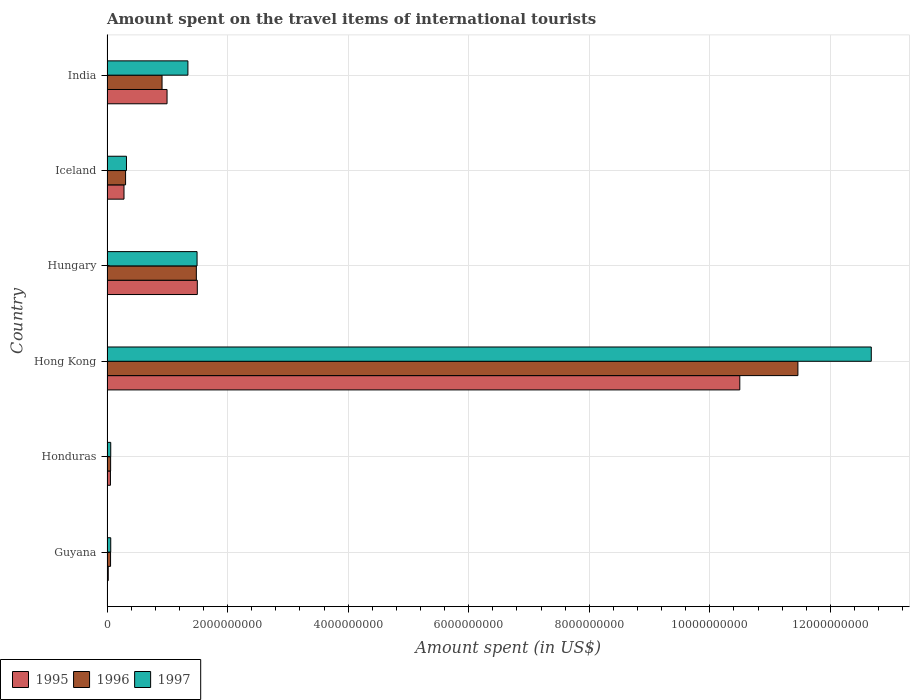How many different coloured bars are there?
Your answer should be compact. 3. How many groups of bars are there?
Make the answer very short. 6. Are the number of bars per tick equal to the number of legend labels?
Provide a succinct answer. Yes. How many bars are there on the 5th tick from the top?
Offer a very short reply. 3. How many bars are there on the 3rd tick from the bottom?
Ensure brevity in your answer.  3. What is the label of the 4th group of bars from the top?
Offer a very short reply. Hong Kong. What is the amount spent on the travel items of international tourists in 1996 in India?
Your answer should be very brief. 9.13e+08. Across all countries, what is the maximum amount spent on the travel items of international tourists in 1997?
Provide a short and direct response. 1.27e+1. Across all countries, what is the minimum amount spent on the travel items of international tourists in 1996?
Your answer should be very brief. 5.90e+07. In which country was the amount spent on the travel items of international tourists in 1995 maximum?
Your answer should be very brief. Hong Kong. In which country was the amount spent on the travel items of international tourists in 1997 minimum?
Give a very brief answer. Guyana. What is the total amount spent on the travel items of international tourists in 1996 in the graph?
Your response must be concise. 1.43e+1. What is the difference between the amount spent on the travel items of international tourists in 1997 in Honduras and that in Hungary?
Your answer should be compact. -1.43e+09. What is the difference between the amount spent on the travel items of international tourists in 1997 in Hong Kong and the amount spent on the travel items of international tourists in 1996 in Iceland?
Offer a very short reply. 1.24e+1. What is the average amount spent on the travel items of international tourists in 1995 per country?
Provide a short and direct response. 2.23e+09. What is the difference between the amount spent on the travel items of international tourists in 1997 and amount spent on the travel items of international tourists in 1996 in Honduras?
Offer a terse response. 2.00e+06. In how many countries, is the amount spent on the travel items of international tourists in 1997 greater than 7600000000 US$?
Your response must be concise. 1. What is the ratio of the amount spent on the travel items of international tourists in 1995 in Honduras to that in Hong Kong?
Make the answer very short. 0.01. Is the amount spent on the travel items of international tourists in 1997 in Honduras less than that in Iceland?
Ensure brevity in your answer.  Yes. What is the difference between the highest and the second highest amount spent on the travel items of international tourists in 1995?
Make the answer very short. 9.00e+09. What is the difference between the highest and the lowest amount spent on the travel items of international tourists in 1997?
Keep it short and to the point. 1.26e+1. In how many countries, is the amount spent on the travel items of international tourists in 1996 greater than the average amount spent on the travel items of international tourists in 1996 taken over all countries?
Your answer should be very brief. 1. Is the sum of the amount spent on the travel items of international tourists in 1995 in Guyana and Honduras greater than the maximum amount spent on the travel items of international tourists in 1997 across all countries?
Provide a short and direct response. No. Is it the case that in every country, the sum of the amount spent on the travel items of international tourists in 1997 and amount spent on the travel items of international tourists in 1996 is greater than the amount spent on the travel items of international tourists in 1995?
Give a very brief answer. Yes. How many bars are there?
Give a very brief answer. 18. Are all the bars in the graph horizontal?
Offer a terse response. Yes. How many countries are there in the graph?
Your response must be concise. 6. What is the difference between two consecutive major ticks on the X-axis?
Provide a succinct answer. 2.00e+09. Are the values on the major ticks of X-axis written in scientific E-notation?
Make the answer very short. No. What is the title of the graph?
Your answer should be compact. Amount spent on the travel items of international tourists. Does "2007" appear as one of the legend labels in the graph?
Keep it short and to the point. No. What is the label or title of the X-axis?
Provide a short and direct response. Amount spent (in US$). What is the Amount spent (in US$) of 1995 in Guyana?
Provide a succinct answer. 2.10e+07. What is the Amount spent (in US$) in 1996 in Guyana?
Your answer should be compact. 5.90e+07. What is the Amount spent (in US$) of 1997 in Guyana?
Keep it short and to the point. 6.20e+07. What is the Amount spent (in US$) of 1995 in Honduras?
Your response must be concise. 5.70e+07. What is the Amount spent (in US$) of 1996 in Honduras?
Give a very brief answer. 6.00e+07. What is the Amount spent (in US$) in 1997 in Honduras?
Ensure brevity in your answer.  6.20e+07. What is the Amount spent (in US$) of 1995 in Hong Kong?
Your response must be concise. 1.05e+1. What is the Amount spent (in US$) of 1996 in Hong Kong?
Provide a succinct answer. 1.15e+1. What is the Amount spent (in US$) in 1997 in Hong Kong?
Offer a terse response. 1.27e+1. What is the Amount spent (in US$) of 1995 in Hungary?
Provide a short and direct response. 1.50e+09. What is the Amount spent (in US$) of 1996 in Hungary?
Give a very brief answer. 1.48e+09. What is the Amount spent (in US$) in 1997 in Hungary?
Keep it short and to the point. 1.49e+09. What is the Amount spent (in US$) of 1995 in Iceland?
Ensure brevity in your answer.  2.82e+08. What is the Amount spent (in US$) in 1996 in Iceland?
Provide a short and direct response. 3.08e+08. What is the Amount spent (in US$) in 1997 in Iceland?
Offer a terse response. 3.23e+08. What is the Amount spent (in US$) in 1995 in India?
Offer a terse response. 9.96e+08. What is the Amount spent (in US$) of 1996 in India?
Provide a short and direct response. 9.13e+08. What is the Amount spent (in US$) of 1997 in India?
Give a very brief answer. 1.34e+09. Across all countries, what is the maximum Amount spent (in US$) of 1995?
Ensure brevity in your answer.  1.05e+1. Across all countries, what is the maximum Amount spent (in US$) in 1996?
Provide a short and direct response. 1.15e+1. Across all countries, what is the maximum Amount spent (in US$) in 1997?
Offer a terse response. 1.27e+1. Across all countries, what is the minimum Amount spent (in US$) of 1995?
Your answer should be compact. 2.10e+07. Across all countries, what is the minimum Amount spent (in US$) of 1996?
Your response must be concise. 5.90e+07. Across all countries, what is the minimum Amount spent (in US$) of 1997?
Offer a very short reply. 6.20e+07. What is the total Amount spent (in US$) in 1995 in the graph?
Your answer should be compact. 1.34e+1. What is the total Amount spent (in US$) in 1996 in the graph?
Offer a terse response. 1.43e+1. What is the total Amount spent (in US$) in 1997 in the graph?
Provide a succinct answer. 1.60e+1. What is the difference between the Amount spent (in US$) in 1995 in Guyana and that in Honduras?
Your answer should be compact. -3.60e+07. What is the difference between the Amount spent (in US$) of 1996 in Guyana and that in Honduras?
Provide a short and direct response. -1.00e+06. What is the difference between the Amount spent (in US$) in 1997 in Guyana and that in Honduras?
Offer a very short reply. 0. What is the difference between the Amount spent (in US$) of 1995 in Guyana and that in Hong Kong?
Your answer should be compact. -1.05e+1. What is the difference between the Amount spent (in US$) in 1996 in Guyana and that in Hong Kong?
Your answer should be compact. -1.14e+1. What is the difference between the Amount spent (in US$) in 1997 in Guyana and that in Hong Kong?
Give a very brief answer. -1.26e+1. What is the difference between the Amount spent (in US$) of 1995 in Guyana and that in Hungary?
Your answer should be very brief. -1.48e+09. What is the difference between the Amount spent (in US$) of 1996 in Guyana and that in Hungary?
Keep it short and to the point. -1.42e+09. What is the difference between the Amount spent (in US$) in 1997 in Guyana and that in Hungary?
Your answer should be compact. -1.43e+09. What is the difference between the Amount spent (in US$) of 1995 in Guyana and that in Iceland?
Give a very brief answer. -2.61e+08. What is the difference between the Amount spent (in US$) of 1996 in Guyana and that in Iceland?
Give a very brief answer. -2.49e+08. What is the difference between the Amount spent (in US$) of 1997 in Guyana and that in Iceland?
Your response must be concise. -2.61e+08. What is the difference between the Amount spent (in US$) of 1995 in Guyana and that in India?
Provide a succinct answer. -9.75e+08. What is the difference between the Amount spent (in US$) in 1996 in Guyana and that in India?
Offer a terse response. -8.54e+08. What is the difference between the Amount spent (in US$) in 1997 in Guyana and that in India?
Offer a terse response. -1.28e+09. What is the difference between the Amount spent (in US$) of 1995 in Honduras and that in Hong Kong?
Give a very brief answer. -1.04e+1. What is the difference between the Amount spent (in US$) in 1996 in Honduras and that in Hong Kong?
Ensure brevity in your answer.  -1.14e+1. What is the difference between the Amount spent (in US$) in 1997 in Honduras and that in Hong Kong?
Give a very brief answer. -1.26e+1. What is the difference between the Amount spent (in US$) in 1995 in Honduras and that in Hungary?
Provide a succinct answer. -1.44e+09. What is the difference between the Amount spent (in US$) in 1996 in Honduras and that in Hungary?
Your response must be concise. -1.42e+09. What is the difference between the Amount spent (in US$) of 1997 in Honduras and that in Hungary?
Ensure brevity in your answer.  -1.43e+09. What is the difference between the Amount spent (in US$) in 1995 in Honduras and that in Iceland?
Give a very brief answer. -2.25e+08. What is the difference between the Amount spent (in US$) in 1996 in Honduras and that in Iceland?
Provide a succinct answer. -2.48e+08. What is the difference between the Amount spent (in US$) in 1997 in Honduras and that in Iceland?
Your response must be concise. -2.61e+08. What is the difference between the Amount spent (in US$) in 1995 in Honduras and that in India?
Give a very brief answer. -9.39e+08. What is the difference between the Amount spent (in US$) of 1996 in Honduras and that in India?
Ensure brevity in your answer.  -8.53e+08. What is the difference between the Amount spent (in US$) in 1997 in Honduras and that in India?
Offer a very short reply. -1.28e+09. What is the difference between the Amount spent (in US$) of 1995 in Hong Kong and that in Hungary?
Ensure brevity in your answer.  9.00e+09. What is the difference between the Amount spent (in US$) of 1996 in Hong Kong and that in Hungary?
Make the answer very short. 9.98e+09. What is the difference between the Amount spent (in US$) of 1997 in Hong Kong and that in Hungary?
Offer a very short reply. 1.12e+1. What is the difference between the Amount spent (in US$) of 1995 in Hong Kong and that in Iceland?
Your answer should be very brief. 1.02e+1. What is the difference between the Amount spent (in US$) in 1996 in Hong Kong and that in Iceland?
Make the answer very short. 1.12e+1. What is the difference between the Amount spent (in US$) in 1997 in Hong Kong and that in Iceland?
Make the answer very short. 1.24e+1. What is the difference between the Amount spent (in US$) in 1995 in Hong Kong and that in India?
Provide a short and direct response. 9.50e+09. What is the difference between the Amount spent (in US$) in 1996 in Hong Kong and that in India?
Your answer should be compact. 1.05e+1. What is the difference between the Amount spent (in US$) of 1997 in Hong Kong and that in India?
Give a very brief answer. 1.13e+1. What is the difference between the Amount spent (in US$) of 1995 in Hungary and that in Iceland?
Your response must be concise. 1.22e+09. What is the difference between the Amount spent (in US$) in 1996 in Hungary and that in Iceland?
Make the answer very short. 1.17e+09. What is the difference between the Amount spent (in US$) in 1997 in Hungary and that in Iceland?
Offer a very short reply. 1.17e+09. What is the difference between the Amount spent (in US$) of 1995 in Hungary and that in India?
Keep it short and to the point. 5.02e+08. What is the difference between the Amount spent (in US$) of 1996 in Hungary and that in India?
Offer a terse response. 5.69e+08. What is the difference between the Amount spent (in US$) of 1997 in Hungary and that in India?
Keep it short and to the point. 1.52e+08. What is the difference between the Amount spent (in US$) in 1995 in Iceland and that in India?
Provide a succinct answer. -7.14e+08. What is the difference between the Amount spent (in US$) of 1996 in Iceland and that in India?
Provide a succinct answer. -6.05e+08. What is the difference between the Amount spent (in US$) in 1997 in Iceland and that in India?
Make the answer very short. -1.02e+09. What is the difference between the Amount spent (in US$) of 1995 in Guyana and the Amount spent (in US$) of 1996 in Honduras?
Provide a short and direct response. -3.90e+07. What is the difference between the Amount spent (in US$) of 1995 in Guyana and the Amount spent (in US$) of 1997 in Honduras?
Your response must be concise. -4.10e+07. What is the difference between the Amount spent (in US$) of 1996 in Guyana and the Amount spent (in US$) of 1997 in Honduras?
Your response must be concise. -3.00e+06. What is the difference between the Amount spent (in US$) of 1995 in Guyana and the Amount spent (in US$) of 1996 in Hong Kong?
Offer a very short reply. -1.14e+1. What is the difference between the Amount spent (in US$) of 1995 in Guyana and the Amount spent (in US$) of 1997 in Hong Kong?
Your answer should be very brief. -1.27e+1. What is the difference between the Amount spent (in US$) of 1996 in Guyana and the Amount spent (in US$) of 1997 in Hong Kong?
Keep it short and to the point. -1.26e+1. What is the difference between the Amount spent (in US$) in 1995 in Guyana and the Amount spent (in US$) in 1996 in Hungary?
Offer a terse response. -1.46e+09. What is the difference between the Amount spent (in US$) in 1995 in Guyana and the Amount spent (in US$) in 1997 in Hungary?
Keep it short and to the point. -1.47e+09. What is the difference between the Amount spent (in US$) of 1996 in Guyana and the Amount spent (in US$) of 1997 in Hungary?
Give a very brief answer. -1.44e+09. What is the difference between the Amount spent (in US$) of 1995 in Guyana and the Amount spent (in US$) of 1996 in Iceland?
Your response must be concise. -2.87e+08. What is the difference between the Amount spent (in US$) in 1995 in Guyana and the Amount spent (in US$) in 1997 in Iceland?
Your answer should be very brief. -3.02e+08. What is the difference between the Amount spent (in US$) in 1996 in Guyana and the Amount spent (in US$) in 1997 in Iceland?
Your answer should be very brief. -2.64e+08. What is the difference between the Amount spent (in US$) of 1995 in Guyana and the Amount spent (in US$) of 1996 in India?
Ensure brevity in your answer.  -8.92e+08. What is the difference between the Amount spent (in US$) of 1995 in Guyana and the Amount spent (in US$) of 1997 in India?
Offer a terse response. -1.32e+09. What is the difference between the Amount spent (in US$) in 1996 in Guyana and the Amount spent (in US$) in 1997 in India?
Offer a very short reply. -1.28e+09. What is the difference between the Amount spent (in US$) of 1995 in Honduras and the Amount spent (in US$) of 1996 in Hong Kong?
Ensure brevity in your answer.  -1.14e+1. What is the difference between the Amount spent (in US$) in 1995 in Honduras and the Amount spent (in US$) in 1997 in Hong Kong?
Provide a short and direct response. -1.26e+1. What is the difference between the Amount spent (in US$) in 1996 in Honduras and the Amount spent (in US$) in 1997 in Hong Kong?
Offer a very short reply. -1.26e+1. What is the difference between the Amount spent (in US$) in 1995 in Honduras and the Amount spent (in US$) in 1996 in Hungary?
Keep it short and to the point. -1.42e+09. What is the difference between the Amount spent (in US$) in 1995 in Honduras and the Amount spent (in US$) in 1997 in Hungary?
Keep it short and to the point. -1.44e+09. What is the difference between the Amount spent (in US$) in 1996 in Honduras and the Amount spent (in US$) in 1997 in Hungary?
Offer a very short reply. -1.43e+09. What is the difference between the Amount spent (in US$) of 1995 in Honduras and the Amount spent (in US$) of 1996 in Iceland?
Provide a succinct answer. -2.51e+08. What is the difference between the Amount spent (in US$) of 1995 in Honduras and the Amount spent (in US$) of 1997 in Iceland?
Ensure brevity in your answer.  -2.66e+08. What is the difference between the Amount spent (in US$) of 1996 in Honduras and the Amount spent (in US$) of 1997 in Iceland?
Your response must be concise. -2.63e+08. What is the difference between the Amount spent (in US$) in 1995 in Honduras and the Amount spent (in US$) in 1996 in India?
Offer a very short reply. -8.56e+08. What is the difference between the Amount spent (in US$) of 1995 in Honduras and the Amount spent (in US$) of 1997 in India?
Your answer should be very brief. -1.28e+09. What is the difference between the Amount spent (in US$) in 1996 in Honduras and the Amount spent (in US$) in 1997 in India?
Your response must be concise. -1.28e+09. What is the difference between the Amount spent (in US$) in 1995 in Hong Kong and the Amount spent (in US$) in 1996 in Hungary?
Provide a succinct answer. 9.02e+09. What is the difference between the Amount spent (in US$) in 1995 in Hong Kong and the Amount spent (in US$) in 1997 in Hungary?
Your answer should be compact. 9.00e+09. What is the difference between the Amount spent (in US$) of 1996 in Hong Kong and the Amount spent (in US$) of 1997 in Hungary?
Make the answer very short. 9.97e+09. What is the difference between the Amount spent (in US$) in 1995 in Hong Kong and the Amount spent (in US$) in 1996 in Iceland?
Give a very brief answer. 1.02e+1. What is the difference between the Amount spent (in US$) in 1995 in Hong Kong and the Amount spent (in US$) in 1997 in Iceland?
Offer a very short reply. 1.02e+1. What is the difference between the Amount spent (in US$) in 1996 in Hong Kong and the Amount spent (in US$) in 1997 in Iceland?
Keep it short and to the point. 1.11e+1. What is the difference between the Amount spent (in US$) in 1995 in Hong Kong and the Amount spent (in US$) in 1996 in India?
Offer a terse response. 9.58e+09. What is the difference between the Amount spent (in US$) in 1995 in Hong Kong and the Amount spent (in US$) in 1997 in India?
Give a very brief answer. 9.16e+09. What is the difference between the Amount spent (in US$) in 1996 in Hong Kong and the Amount spent (in US$) in 1997 in India?
Offer a very short reply. 1.01e+1. What is the difference between the Amount spent (in US$) of 1995 in Hungary and the Amount spent (in US$) of 1996 in Iceland?
Your answer should be compact. 1.19e+09. What is the difference between the Amount spent (in US$) in 1995 in Hungary and the Amount spent (in US$) in 1997 in Iceland?
Keep it short and to the point. 1.18e+09. What is the difference between the Amount spent (in US$) of 1996 in Hungary and the Amount spent (in US$) of 1997 in Iceland?
Keep it short and to the point. 1.16e+09. What is the difference between the Amount spent (in US$) in 1995 in Hungary and the Amount spent (in US$) in 1996 in India?
Keep it short and to the point. 5.85e+08. What is the difference between the Amount spent (in US$) of 1995 in Hungary and the Amount spent (in US$) of 1997 in India?
Provide a succinct answer. 1.56e+08. What is the difference between the Amount spent (in US$) of 1996 in Hungary and the Amount spent (in US$) of 1997 in India?
Provide a succinct answer. 1.40e+08. What is the difference between the Amount spent (in US$) of 1995 in Iceland and the Amount spent (in US$) of 1996 in India?
Keep it short and to the point. -6.31e+08. What is the difference between the Amount spent (in US$) in 1995 in Iceland and the Amount spent (in US$) in 1997 in India?
Your answer should be compact. -1.06e+09. What is the difference between the Amount spent (in US$) of 1996 in Iceland and the Amount spent (in US$) of 1997 in India?
Make the answer very short. -1.03e+09. What is the average Amount spent (in US$) in 1995 per country?
Your answer should be very brief. 2.23e+09. What is the average Amount spent (in US$) in 1996 per country?
Offer a very short reply. 2.38e+09. What is the average Amount spent (in US$) of 1997 per country?
Provide a short and direct response. 2.66e+09. What is the difference between the Amount spent (in US$) of 1995 and Amount spent (in US$) of 1996 in Guyana?
Make the answer very short. -3.80e+07. What is the difference between the Amount spent (in US$) in 1995 and Amount spent (in US$) in 1997 in Guyana?
Keep it short and to the point. -4.10e+07. What is the difference between the Amount spent (in US$) in 1995 and Amount spent (in US$) in 1996 in Honduras?
Provide a succinct answer. -3.00e+06. What is the difference between the Amount spent (in US$) of 1995 and Amount spent (in US$) of 1997 in Honduras?
Provide a succinct answer. -5.00e+06. What is the difference between the Amount spent (in US$) of 1996 and Amount spent (in US$) of 1997 in Honduras?
Offer a very short reply. -2.00e+06. What is the difference between the Amount spent (in US$) in 1995 and Amount spent (in US$) in 1996 in Hong Kong?
Provide a succinct answer. -9.64e+08. What is the difference between the Amount spent (in US$) in 1995 and Amount spent (in US$) in 1997 in Hong Kong?
Your response must be concise. -2.18e+09. What is the difference between the Amount spent (in US$) in 1996 and Amount spent (in US$) in 1997 in Hong Kong?
Offer a very short reply. -1.22e+09. What is the difference between the Amount spent (in US$) in 1995 and Amount spent (in US$) in 1996 in Hungary?
Give a very brief answer. 1.60e+07. What is the difference between the Amount spent (in US$) of 1996 and Amount spent (in US$) of 1997 in Hungary?
Offer a very short reply. -1.20e+07. What is the difference between the Amount spent (in US$) in 1995 and Amount spent (in US$) in 1996 in Iceland?
Your answer should be compact. -2.60e+07. What is the difference between the Amount spent (in US$) of 1995 and Amount spent (in US$) of 1997 in Iceland?
Provide a succinct answer. -4.10e+07. What is the difference between the Amount spent (in US$) of 1996 and Amount spent (in US$) of 1997 in Iceland?
Provide a succinct answer. -1.50e+07. What is the difference between the Amount spent (in US$) of 1995 and Amount spent (in US$) of 1996 in India?
Give a very brief answer. 8.30e+07. What is the difference between the Amount spent (in US$) of 1995 and Amount spent (in US$) of 1997 in India?
Give a very brief answer. -3.46e+08. What is the difference between the Amount spent (in US$) of 1996 and Amount spent (in US$) of 1997 in India?
Your response must be concise. -4.29e+08. What is the ratio of the Amount spent (in US$) of 1995 in Guyana to that in Honduras?
Your answer should be very brief. 0.37. What is the ratio of the Amount spent (in US$) in 1996 in Guyana to that in Honduras?
Make the answer very short. 0.98. What is the ratio of the Amount spent (in US$) of 1997 in Guyana to that in Honduras?
Make the answer very short. 1. What is the ratio of the Amount spent (in US$) of 1995 in Guyana to that in Hong Kong?
Offer a terse response. 0. What is the ratio of the Amount spent (in US$) of 1996 in Guyana to that in Hong Kong?
Keep it short and to the point. 0.01. What is the ratio of the Amount spent (in US$) of 1997 in Guyana to that in Hong Kong?
Your response must be concise. 0. What is the ratio of the Amount spent (in US$) of 1995 in Guyana to that in Hungary?
Make the answer very short. 0.01. What is the ratio of the Amount spent (in US$) of 1996 in Guyana to that in Hungary?
Offer a terse response. 0.04. What is the ratio of the Amount spent (in US$) of 1997 in Guyana to that in Hungary?
Offer a very short reply. 0.04. What is the ratio of the Amount spent (in US$) in 1995 in Guyana to that in Iceland?
Your answer should be compact. 0.07. What is the ratio of the Amount spent (in US$) of 1996 in Guyana to that in Iceland?
Provide a short and direct response. 0.19. What is the ratio of the Amount spent (in US$) in 1997 in Guyana to that in Iceland?
Your response must be concise. 0.19. What is the ratio of the Amount spent (in US$) in 1995 in Guyana to that in India?
Your answer should be compact. 0.02. What is the ratio of the Amount spent (in US$) of 1996 in Guyana to that in India?
Ensure brevity in your answer.  0.06. What is the ratio of the Amount spent (in US$) of 1997 in Guyana to that in India?
Offer a very short reply. 0.05. What is the ratio of the Amount spent (in US$) in 1995 in Honduras to that in Hong Kong?
Your response must be concise. 0.01. What is the ratio of the Amount spent (in US$) of 1996 in Honduras to that in Hong Kong?
Offer a very short reply. 0.01. What is the ratio of the Amount spent (in US$) in 1997 in Honduras to that in Hong Kong?
Ensure brevity in your answer.  0. What is the ratio of the Amount spent (in US$) of 1995 in Honduras to that in Hungary?
Your answer should be compact. 0.04. What is the ratio of the Amount spent (in US$) in 1996 in Honduras to that in Hungary?
Ensure brevity in your answer.  0.04. What is the ratio of the Amount spent (in US$) of 1997 in Honduras to that in Hungary?
Offer a very short reply. 0.04. What is the ratio of the Amount spent (in US$) of 1995 in Honduras to that in Iceland?
Offer a terse response. 0.2. What is the ratio of the Amount spent (in US$) of 1996 in Honduras to that in Iceland?
Your answer should be very brief. 0.19. What is the ratio of the Amount spent (in US$) of 1997 in Honduras to that in Iceland?
Provide a succinct answer. 0.19. What is the ratio of the Amount spent (in US$) of 1995 in Honduras to that in India?
Make the answer very short. 0.06. What is the ratio of the Amount spent (in US$) of 1996 in Honduras to that in India?
Give a very brief answer. 0.07. What is the ratio of the Amount spent (in US$) in 1997 in Honduras to that in India?
Keep it short and to the point. 0.05. What is the ratio of the Amount spent (in US$) in 1995 in Hong Kong to that in Hungary?
Offer a very short reply. 7.01. What is the ratio of the Amount spent (in US$) in 1996 in Hong Kong to that in Hungary?
Keep it short and to the point. 7.73. What is the ratio of the Amount spent (in US$) of 1997 in Hong Kong to that in Hungary?
Provide a succinct answer. 8.49. What is the ratio of the Amount spent (in US$) of 1995 in Hong Kong to that in Iceland?
Your response must be concise. 37.22. What is the ratio of the Amount spent (in US$) of 1996 in Hong Kong to that in Iceland?
Provide a short and direct response. 37.21. What is the ratio of the Amount spent (in US$) in 1997 in Hong Kong to that in Iceland?
Make the answer very short. 39.25. What is the ratio of the Amount spent (in US$) in 1995 in Hong Kong to that in India?
Ensure brevity in your answer.  10.54. What is the ratio of the Amount spent (in US$) in 1996 in Hong Kong to that in India?
Ensure brevity in your answer.  12.55. What is the ratio of the Amount spent (in US$) of 1997 in Hong Kong to that in India?
Make the answer very short. 9.45. What is the ratio of the Amount spent (in US$) of 1995 in Hungary to that in Iceland?
Your answer should be compact. 5.31. What is the ratio of the Amount spent (in US$) in 1996 in Hungary to that in Iceland?
Make the answer very short. 4.81. What is the ratio of the Amount spent (in US$) of 1997 in Hungary to that in Iceland?
Ensure brevity in your answer.  4.63. What is the ratio of the Amount spent (in US$) of 1995 in Hungary to that in India?
Offer a terse response. 1.5. What is the ratio of the Amount spent (in US$) of 1996 in Hungary to that in India?
Keep it short and to the point. 1.62. What is the ratio of the Amount spent (in US$) in 1997 in Hungary to that in India?
Provide a short and direct response. 1.11. What is the ratio of the Amount spent (in US$) of 1995 in Iceland to that in India?
Give a very brief answer. 0.28. What is the ratio of the Amount spent (in US$) in 1996 in Iceland to that in India?
Your answer should be compact. 0.34. What is the ratio of the Amount spent (in US$) in 1997 in Iceland to that in India?
Your answer should be very brief. 0.24. What is the difference between the highest and the second highest Amount spent (in US$) in 1995?
Offer a terse response. 9.00e+09. What is the difference between the highest and the second highest Amount spent (in US$) of 1996?
Your response must be concise. 9.98e+09. What is the difference between the highest and the second highest Amount spent (in US$) of 1997?
Your response must be concise. 1.12e+1. What is the difference between the highest and the lowest Amount spent (in US$) of 1995?
Provide a short and direct response. 1.05e+1. What is the difference between the highest and the lowest Amount spent (in US$) of 1996?
Keep it short and to the point. 1.14e+1. What is the difference between the highest and the lowest Amount spent (in US$) of 1997?
Provide a short and direct response. 1.26e+1. 